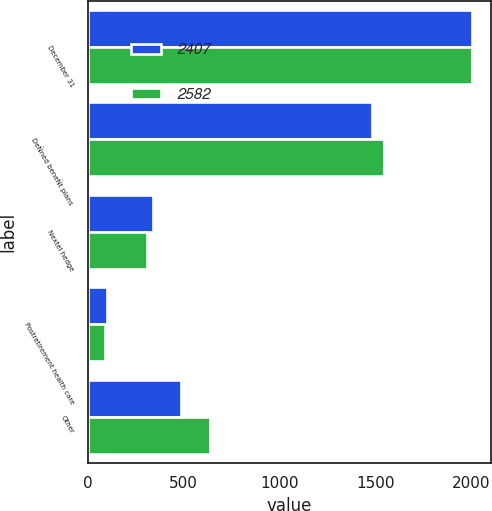<chart> <loc_0><loc_0><loc_500><loc_500><stacked_bar_chart><ecel><fcel>December 31<fcel>DeÑned beneÑt plans<fcel>Nextel hedge<fcel>Postretirement health care<fcel>Other<nl><fcel>2407<fcel>2004<fcel>1481<fcel>340<fcel>100<fcel>486<nl><fcel>2582<fcel>2003<fcel>1546<fcel>310<fcel>90<fcel>636<nl></chart> 